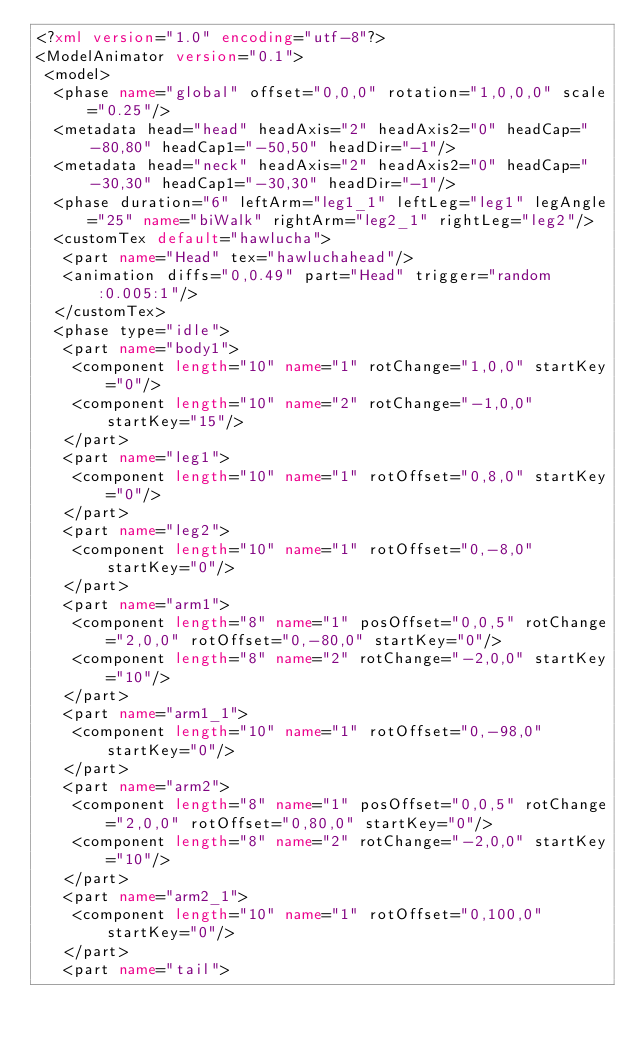Convert code to text. <code><loc_0><loc_0><loc_500><loc_500><_XML_><?xml version="1.0" encoding="utf-8"?>
<ModelAnimator version="0.1">
 <model>
  <phase name="global" offset="0,0,0" rotation="1,0,0,0" scale="0.25"/>
  <metadata head="head" headAxis="2" headAxis2="0" headCap="-80,80" headCap1="-50,50" headDir="-1"/>
  <metadata head="neck" headAxis="2" headAxis2="0" headCap="-30,30" headCap1="-30,30" headDir="-1"/>
  <phase duration="6" leftArm="leg1_1" leftLeg="leg1" legAngle="25" name="biWalk" rightArm="leg2_1" rightLeg="leg2"/>
  <customTex default="hawlucha">
   <part name="Head" tex="hawluchahead"/>
   <animation diffs="0,0.49" part="Head" trigger="random:0.005:1"/>
  </customTex>
  <phase type="idle">
   <part name="body1">
    <component length="10" name="1" rotChange="1,0,0" startKey="0"/>
    <component length="10" name="2" rotChange="-1,0,0" startKey="15"/>
   </part>
   <part name="leg1">
    <component length="10" name="1" rotOffset="0,8,0" startKey="0"/>
   </part>
   <part name="leg2">
    <component length="10" name="1" rotOffset="0,-8,0" startKey="0"/>
   </part>
   <part name="arm1">
    <component length="8" name="1" posOffset="0,0,5" rotChange="2,0,0" rotOffset="0,-80,0" startKey="0"/>
    <component length="8" name="2" rotChange="-2,0,0" startKey="10"/>
   </part>
   <part name="arm1_1">
    <component length="10" name="1" rotOffset="0,-98,0" startKey="0"/>
   </part>
   <part name="arm2">
    <component length="8" name="1" posOffset="0,0,5" rotChange="2,0,0" rotOffset="0,80,0" startKey="0"/>
    <component length="8" name="2" rotChange="-2,0,0" startKey="10"/>
   </part>
   <part name="arm2_1">
    <component length="10" name="1" rotOffset="0,100,0" startKey="0"/>
   </part>
   <part name="tail"></code> 